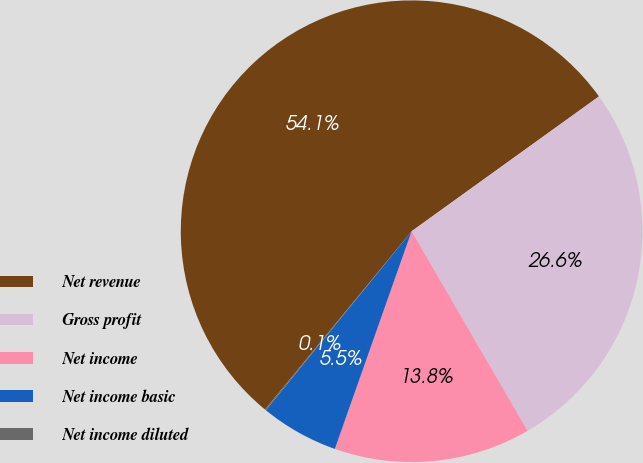Convert chart to OTSL. <chart><loc_0><loc_0><loc_500><loc_500><pie_chart><fcel>Net revenue<fcel>Gross profit<fcel>Net income<fcel>Net income basic<fcel>Net income diluted<nl><fcel>54.11%<fcel>26.55%<fcel>13.77%<fcel>5.48%<fcel>0.08%<nl></chart> 